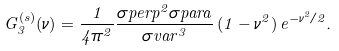<formula> <loc_0><loc_0><loc_500><loc_500>G _ { 3 } ^ { ( s ) } ( \nu ) = \frac { 1 } { 4 \pi ^ { 2 } } \frac { \sigma p e r p ^ { 2 } \sigma p a r a } { \sigma v a r ^ { 3 } } \, ( 1 - \nu ^ { 2 } ) \, e ^ { - \nu ^ { 2 } / 2 } .</formula> 